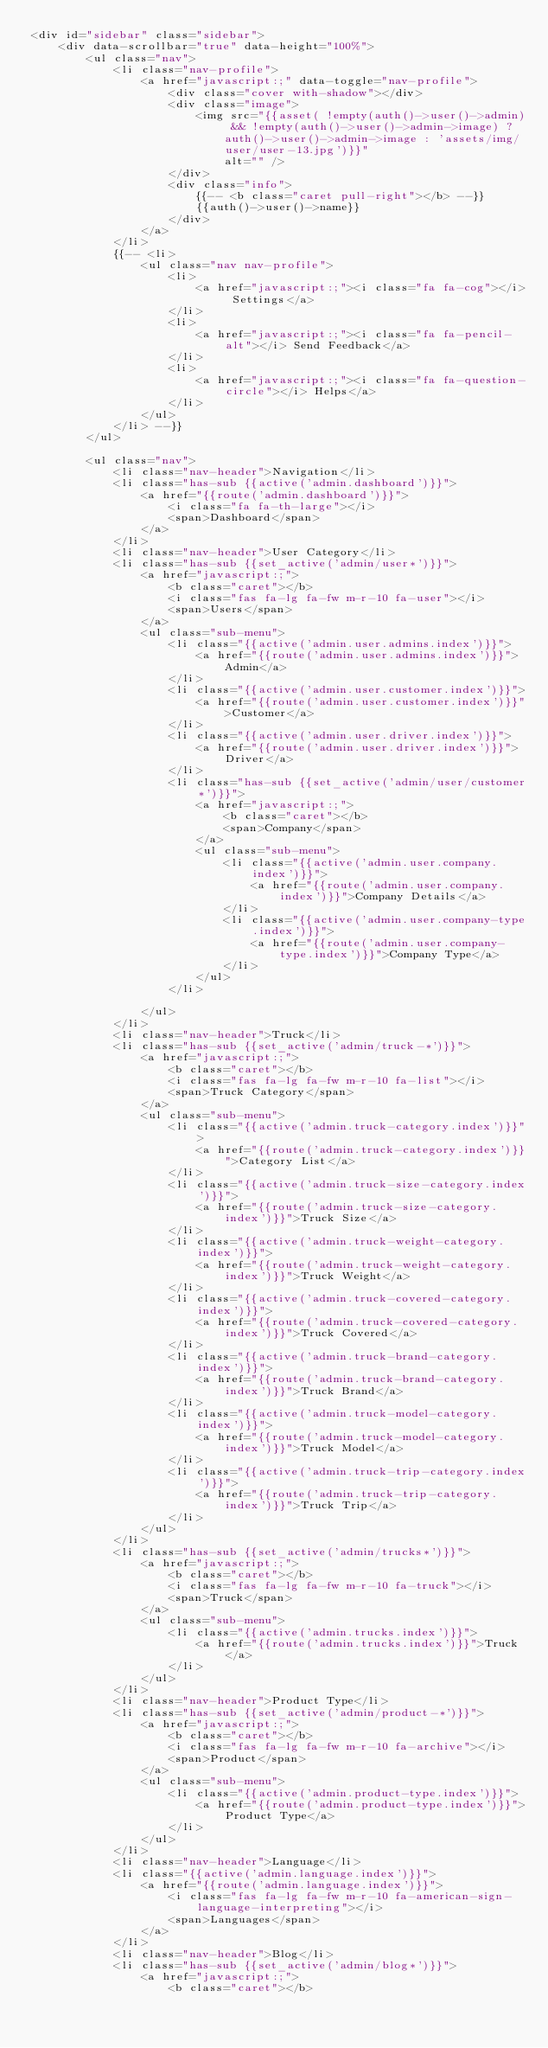Convert code to text. <code><loc_0><loc_0><loc_500><loc_500><_PHP_><div id="sidebar" class="sidebar">
    <div data-scrollbar="true" data-height="100%">
        <ul class="nav">
            <li class="nav-profile">
                <a href="javascript:;" data-toggle="nav-profile">
                    <div class="cover with-shadow"></div>
                    <div class="image">
                        <img src="{{asset( !empty(auth()->user()->admin) && !empty(auth()->user()->admin->image) ? auth()->user()->admin->image : 'assets/img/user/user-13.jpg')}}"
                            alt="" />
                    </div>
                    <div class="info">
                        {{-- <b class="caret pull-right"></b> --}}
                        {{auth()->user()->name}}
                    </div>
                </a>
            </li>
            {{-- <li>
                <ul class="nav nav-profile">
                    <li>
                        <a href="javascript:;"><i class="fa fa-cog"></i> Settings</a>
                    </li>
                    <li>
                        <a href="javascript:;"><i class="fa fa-pencil-alt"></i> Send Feedback</a>
                    </li>
                    <li>
                        <a href="javascript:;"><i class="fa fa-question-circle"></i> Helps</a>
                    </li>
                </ul>
            </li> --}}
        </ul>

        <ul class="nav">
            <li class="nav-header">Navigation</li>
            <li class="has-sub {{active('admin.dashboard')}}">
                <a href="{{route('admin.dashboard')}}">
                    <i class="fa fa-th-large"></i>
                    <span>Dashboard</span>
                </a>
            </li>
            <li class="nav-header">User Category</li>
            <li class="has-sub {{set_active('admin/user*')}}">
                <a href="javascript:;">
                    <b class="caret"></b>
                    <i class="fas fa-lg fa-fw m-r-10 fa-user"></i>
                    <span>Users</span>
                </a>
                <ul class="sub-menu">
                    <li class="{{active('admin.user.admins.index')}}">
                        <a href="{{route('admin.user.admins.index')}}">Admin</a>
                    </li>
                    <li class="{{active('admin.user.customer.index')}}">
                        <a href="{{route('admin.user.customer.index')}}">Customer</a>
                    </li>
                    <li class="{{active('admin.user.driver.index')}}">
                        <a href="{{route('admin.user.driver.index')}}">Driver</a>
                    </li>
                    <li class="has-sub {{set_active('admin/user/customer*')}}">
                        <a href="javascript:;">
                            <b class="caret"></b>
                            <span>Company</span>
                        </a>
                        <ul class="sub-menu">
                            <li class="{{active('admin.user.company.index')}}">
                                <a href="{{route('admin.user.company.index')}}">Company Details</a>
                            </li>
                            <li class="{{active('admin.user.company-type.index')}}">
                                <a href="{{route('admin.user.company-type.index')}}">Company Type</a>
                            </li>
                        </ul>
                    </li>

                </ul>
            </li>
            <li class="nav-header">Truck</li>
            <li class="has-sub {{set_active('admin/truck-*')}}">
                <a href="javascript:;">
                    <b class="caret"></b>
                    <i class="fas fa-lg fa-fw m-r-10 fa-list"></i>
                    <span>Truck Category</span>
                </a>
                <ul class="sub-menu">
                    <li class="{{active('admin.truck-category.index')}}">
                        <a href="{{route('admin.truck-category.index')}}">Category List</a>
                    </li>
                    <li class="{{active('admin.truck-size-category.index')}}">
                        <a href="{{route('admin.truck-size-category.index')}}">Truck Size</a>
                    </li>
                    <li class="{{active('admin.truck-weight-category.index')}}">
                        <a href="{{route('admin.truck-weight-category.index')}}">Truck Weight</a>
                    </li>
                    <li class="{{active('admin.truck-covered-category.index')}}">
                        <a href="{{route('admin.truck-covered-category.index')}}">Truck Covered</a>
                    </li>
                    <li class="{{active('admin.truck-brand-category.index')}}">
                        <a href="{{route('admin.truck-brand-category.index')}}">Truck Brand</a>
                    </li>
                    <li class="{{active('admin.truck-model-category.index')}}">
                        <a href="{{route('admin.truck-model-category.index')}}">Truck Model</a>
                    </li>
                    <li class="{{active('admin.truck-trip-category.index')}}">
                        <a href="{{route('admin.truck-trip-category.index')}}">Truck Trip</a>
                    </li>
                </ul>
            </li>
            <li class="has-sub {{set_active('admin/trucks*')}}">
                <a href="javascript:;">
                    <b class="caret"></b>
                    <i class="fas fa-lg fa-fw m-r-10 fa-truck"></i>
                    <span>Truck</span>
                </a>
                <ul class="sub-menu">
                    <li class="{{active('admin.trucks.index')}}">
                        <a href="{{route('admin.trucks.index')}}">Truck</a>
                    </li>
                </ul>
            </li>
            <li class="nav-header">Product Type</li>
            <li class="has-sub {{set_active('admin/product-*')}}">
                <a href="javascript:;">
                    <b class="caret"></b>
                    <i class="fas fa-lg fa-fw m-r-10 fa-archive"></i>
                    <span>Product</span>
                </a>
                <ul class="sub-menu">
                    <li class="{{active('admin.product-type.index')}}">
                        <a href="{{route('admin.product-type.index')}}">Product Type</a>
                    </li>
                </ul>
            </li>
            <li class="nav-header">Language</li>
            <li class="{{active('admin.language.index')}}">
                <a href="{{route('admin.language.index')}}">
                    <i class="fas fa-lg fa-fw m-r-10 fa-american-sign-language-interpreting"></i>
                    <span>Languages</span>
                </a>
            </li>
            <li class="nav-header">Blog</li>
            <li class="has-sub {{set_active('admin/blog*')}}">
                <a href="javascript:;">
                    <b class="caret"></b></code> 